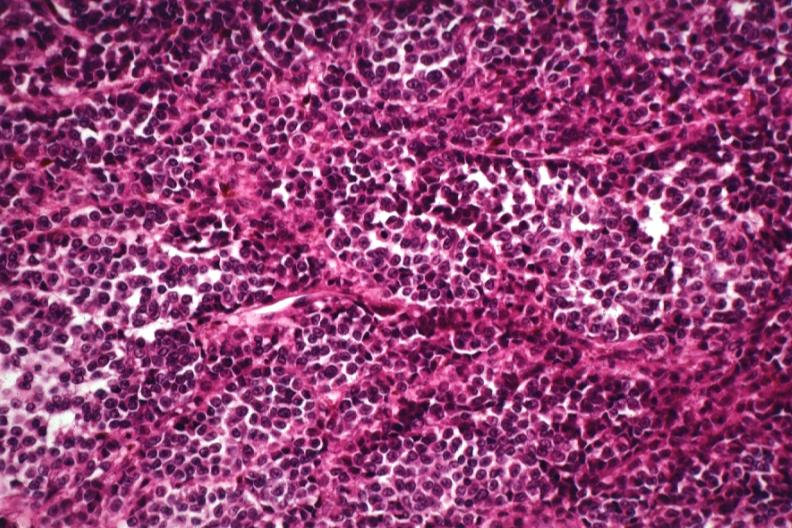what is present?
Answer the question using a single word or phrase. Malignant melanoma 